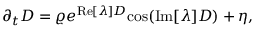<formula> <loc_0><loc_0><loc_500><loc_500>\partial _ { t } D = \varrho e ^ { R e [ \lambda ] D } \cos ( I m [ \lambda ] D ) + \eta ,</formula> 